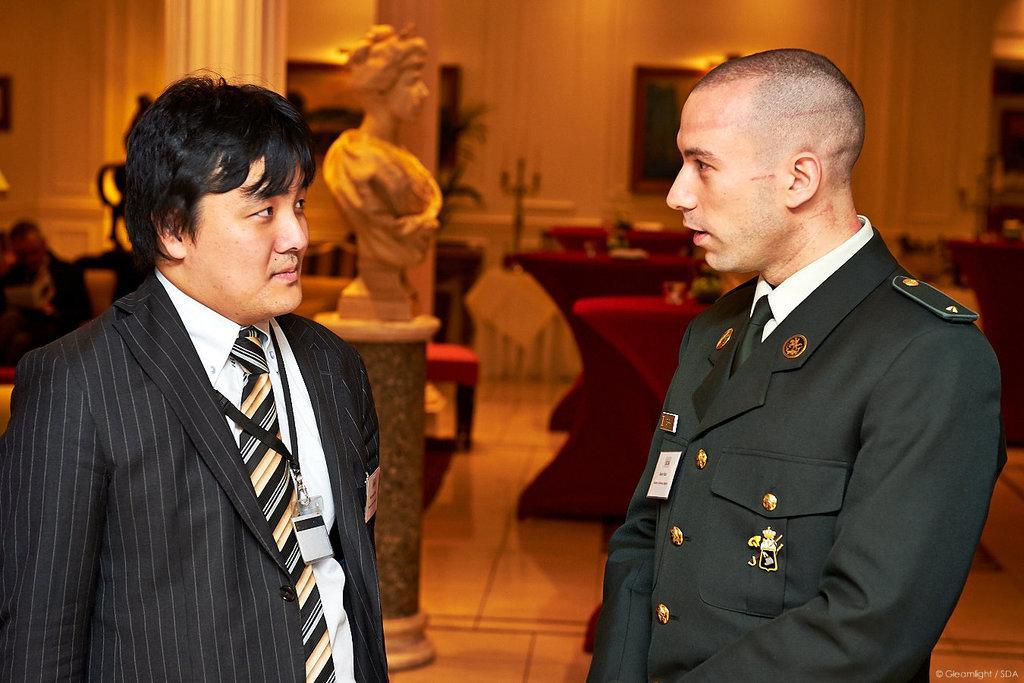Describe this image in one or two sentences. In this image there are two officers who are standing by facing each other. In the background there is a statue. On the right side there are tables. On the left side there is a pillar. Beside the pillar there is a chair. In the background there is a wall to which there is a photo frame. 